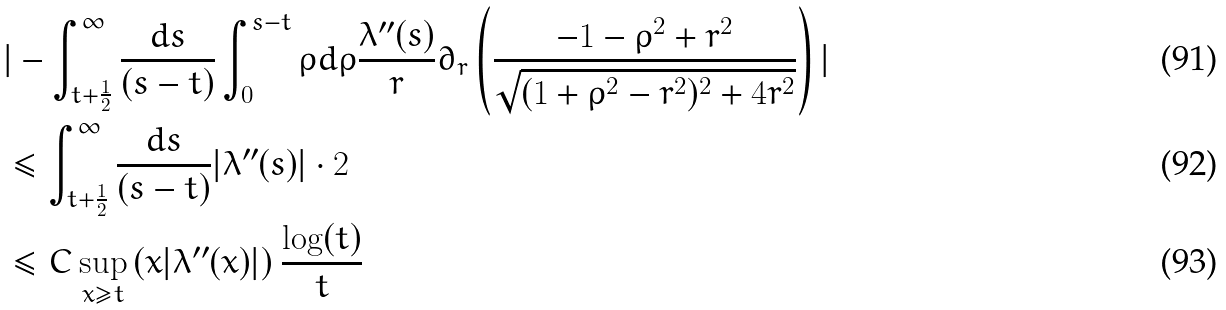Convert formula to latex. <formula><loc_0><loc_0><loc_500><loc_500>& | - \int _ { t + \frac { 1 } { 2 } } ^ { \infty } \frac { d s } { ( s - t ) } \int _ { 0 } ^ { s - t } \rho d \rho \frac { \lambda ^ { \prime \prime } ( s ) } { r } \partial _ { r } \left ( \frac { - 1 - \rho ^ { 2 } + r ^ { 2 } } { \sqrt { ( 1 + \rho ^ { 2 } - r ^ { 2 } ) ^ { 2 } + 4 r ^ { 2 } } } \right ) | \\ & \leq \int _ { t + \frac { 1 } { 2 } } ^ { \infty } \frac { d s } { ( s - t ) } | \lambda ^ { \prime \prime } ( s ) | \cdot 2 \\ & \leq C \sup _ { x \geq t } \left ( x | \lambda ^ { \prime \prime } ( x ) | \right ) \frac { \log ( t ) } { t }</formula> 